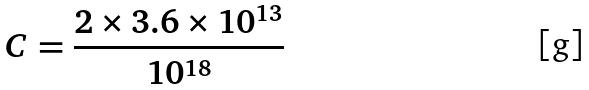<formula> <loc_0><loc_0><loc_500><loc_500>C = \frac { 2 \times 3 . 6 \times 1 0 ^ { 1 3 } } { 1 0 ^ { 1 8 } }</formula> 